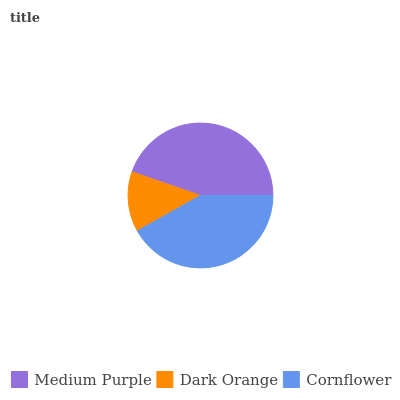Is Dark Orange the minimum?
Answer yes or no. Yes. Is Medium Purple the maximum?
Answer yes or no. Yes. Is Cornflower the minimum?
Answer yes or no. No. Is Cornflower the maximum?
Answer yes or no. No. Is Cornflower greater than Dark Orange?
Answer yes or no. Yes. Is Dark Orange less than Cornflower?
Answer yes or no. Yes. Is Dark Orange greater than Cornflower?
Answer yes or no. No. Is Cornflower less than Dark Orange?
Answer yes or no. No. Is Cornflower the high median?
Answer yes or no. Yes. Is Cornflower the low median?
Answer yes or no. Yes. Is Medium Purple the high median?
Answer yes or no. No. Is Medium Purple the low median?
Answer yes or no. No. 